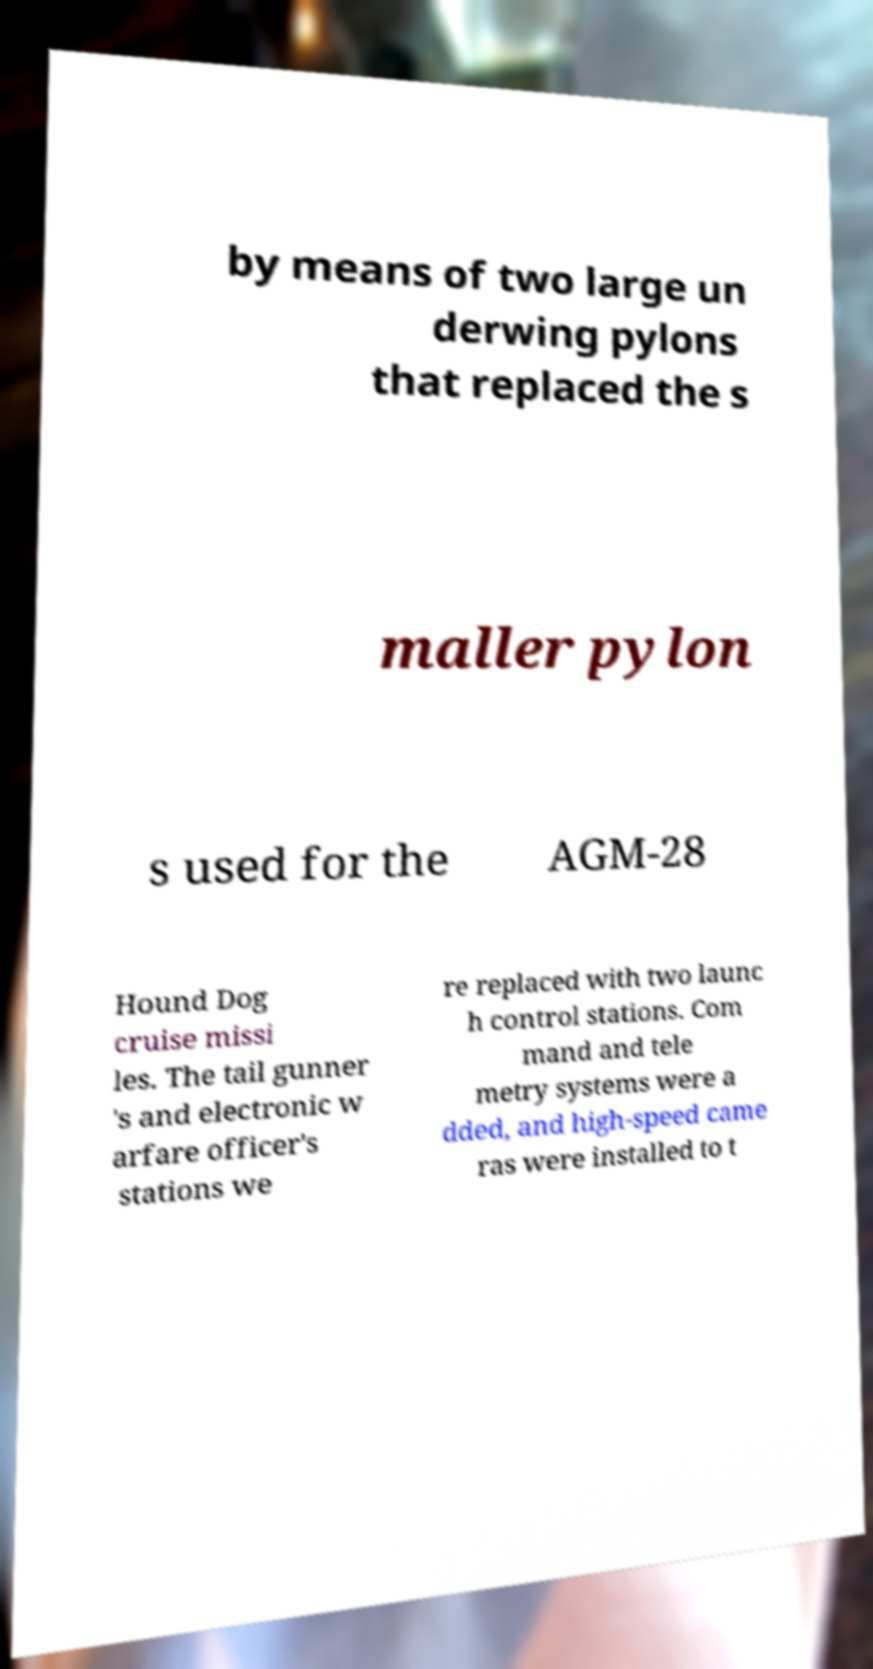Could you extract and type out the text from this image? by means of two large un derwing pylons that replaced the s maller pylon s used for the AGM-28 Hound Dog cruise missi les. The tail gunner 's and electronic w arfare officer's stations we re replaced with two launc h control stations. Com mand and tele metry systems were a dded, and high-speed came ras were installed to t 